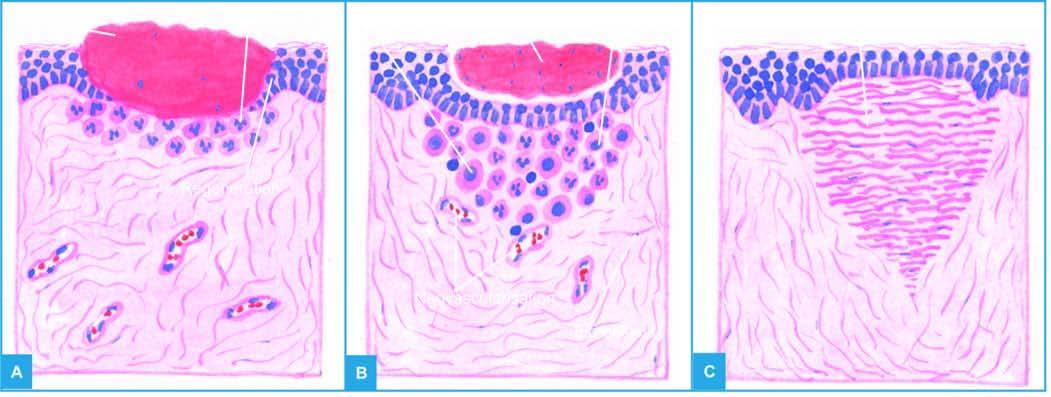s the interface between viable and non-viable area filled with blood clot?
Answer the question using a single word or phrase. No 